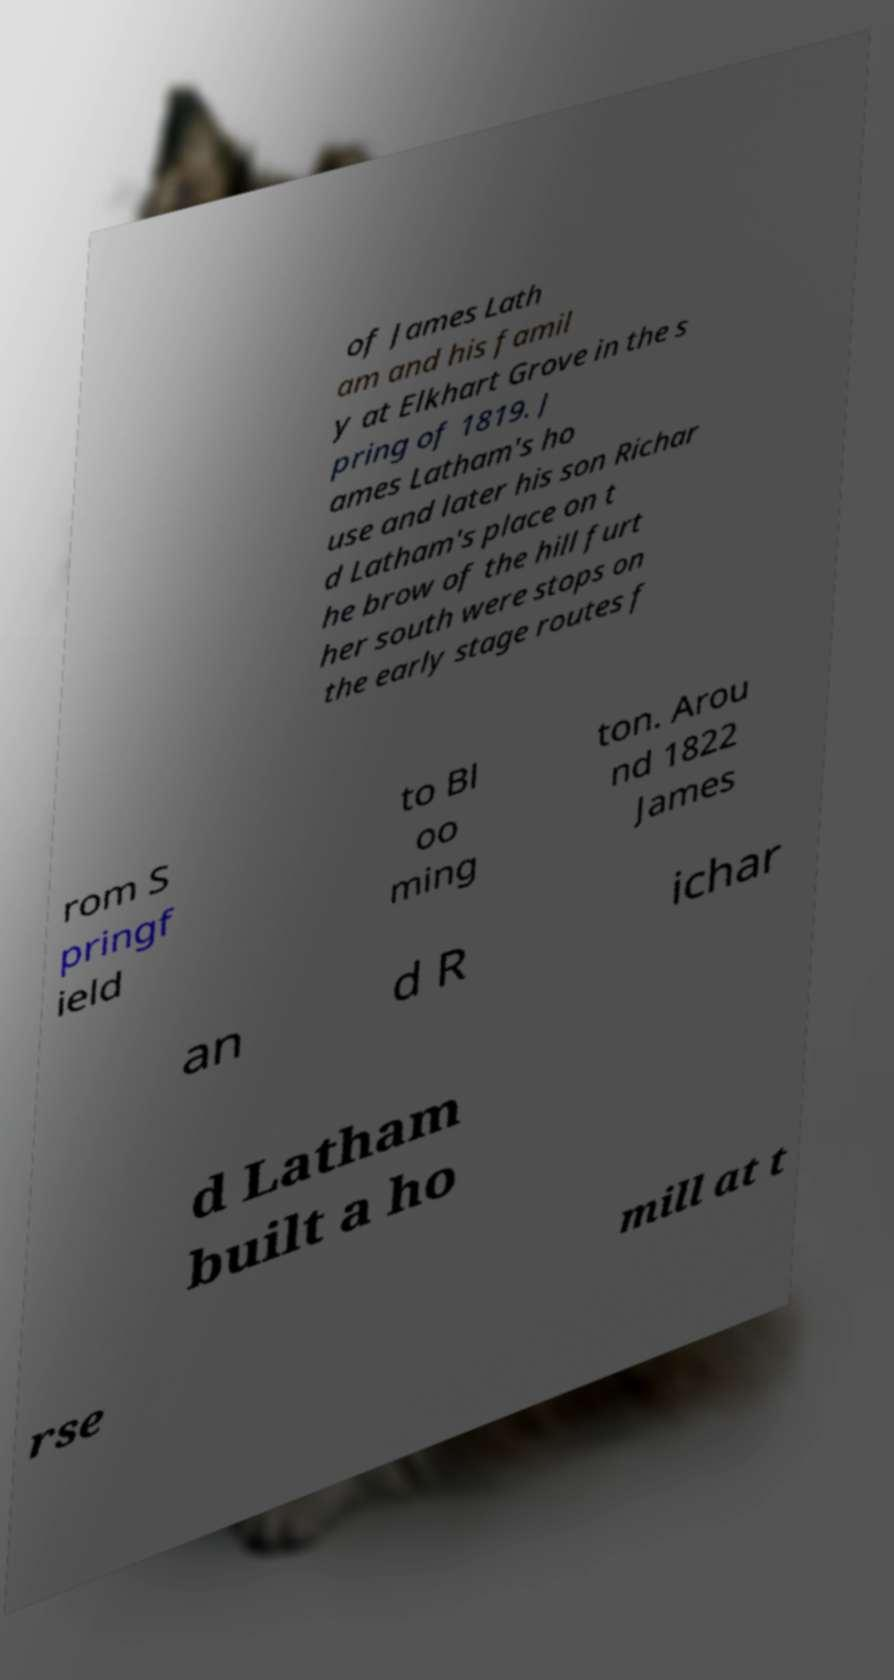Could you assist in decoding the text presented in this image and type it out clearly? of James Lath am and his famil y at Elkhart Grove in the s pring of 1819. J ames Latham's ho use and later his son Richar d Latham's place on t he brow of the hill furt her south were stops on the early stage routes f rom S pringf ield to Bl oo ming ton. Arou nd 1822 James an d R ichar d Latham built a ho rse mill at t 